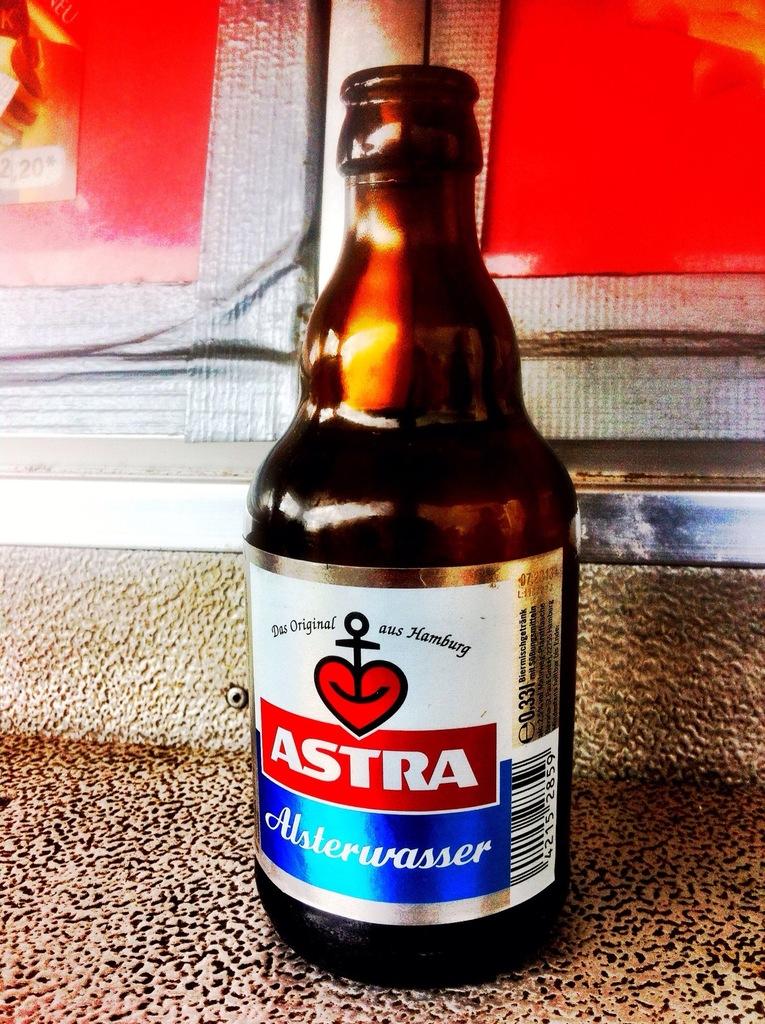Is this a bottle of astra?
Offer a terse response. Yes. What is the name of the city on the top right of the bottle?
Give a very brief answer. Hamburg. 